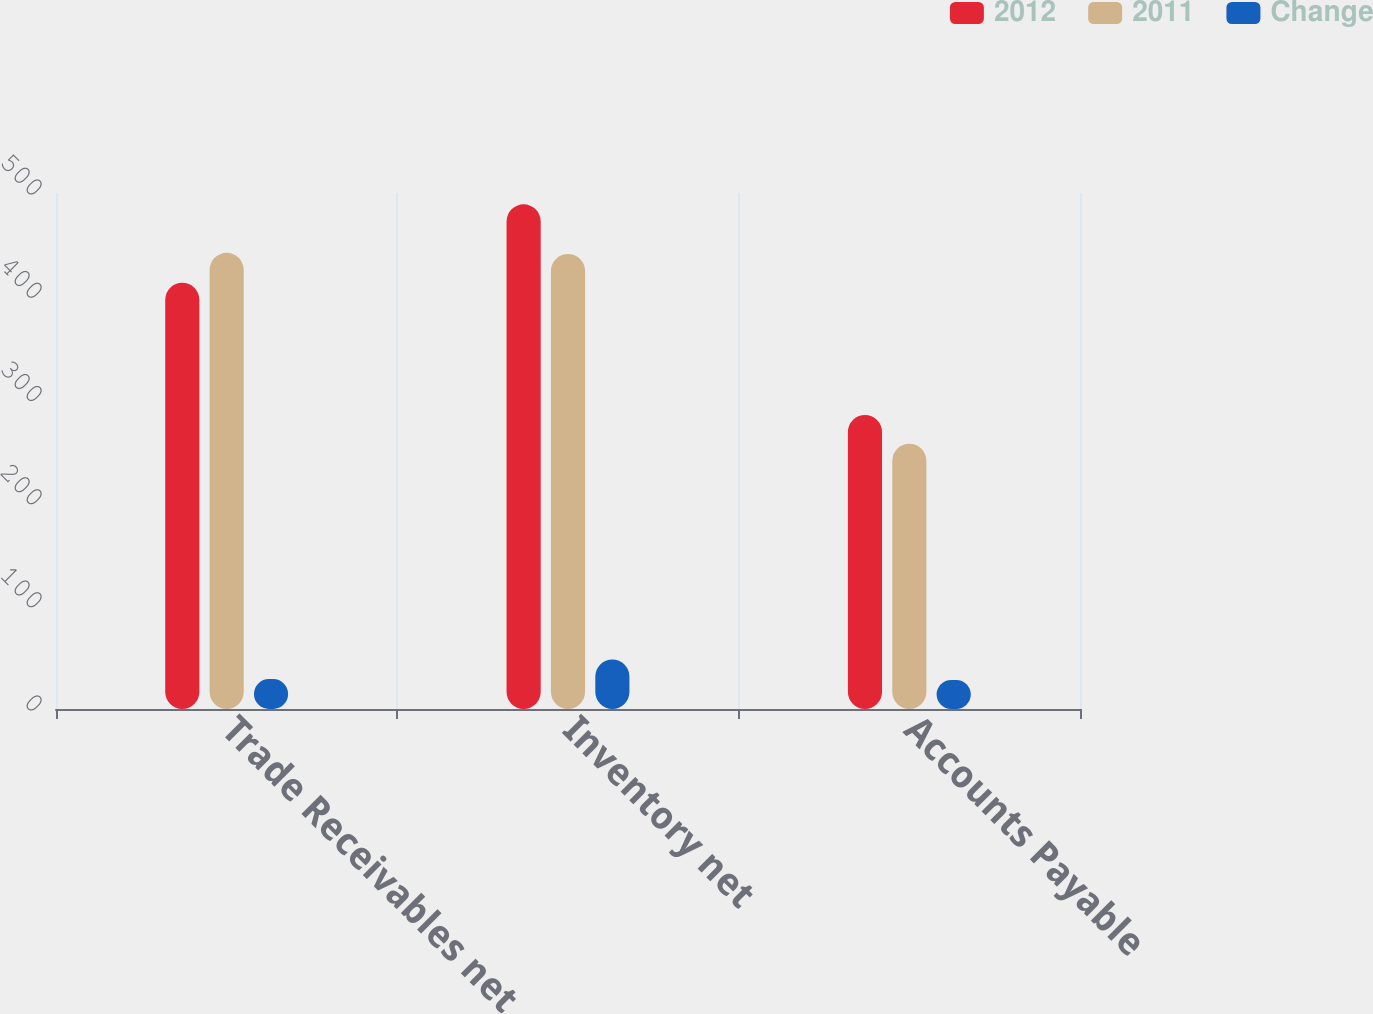<chart> <loc_0><loc_0><loc_500><loc_500><stacked_bar_chart><ecel><fcel>Trade Receivables net<fcel>Inventory net<fcel>Accounts Payable<nl><fcel>2012<fcel>413<fcel>489<fcel>285<nl><fcel>2011<fcel>442<fcel>441<fcel>257<nl><fcel>Change<fcel>29<fcel>48<fcel>28<nl></chart> 